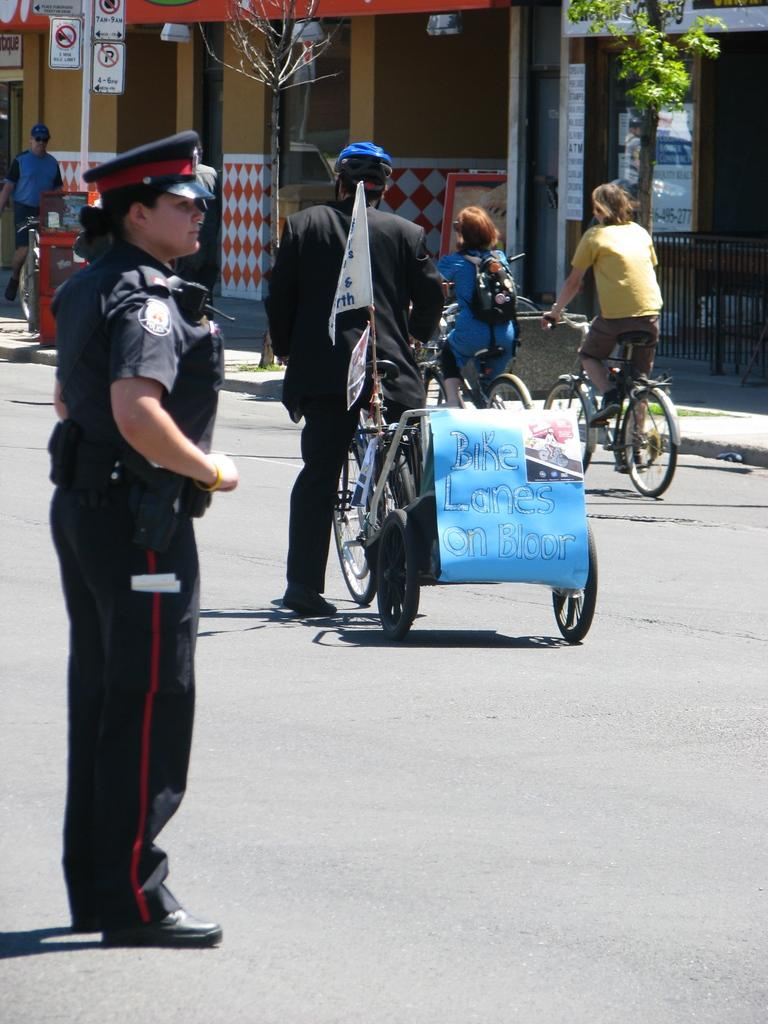Where was the image taken? The image was taken outside. How many people can be seen in the image? There are many people in the image. What are some people doing in the image? Some people are riding bicycles. What can be seen in the background of the image? There are trees and stores visible in the image. How many icicles are hanging from the trees in the image? There are no icicles visible in the image, as it was taken outside and there are trees present, but no indication of icicles. 